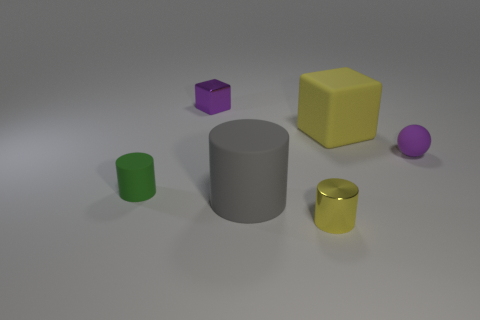There is a large yellow rubber thing; is it the same shape as the metallic thing that is to the left of the gray thing?
Offer a very short reply. Yes. How many small matte things are the same shape as the large gray matte object?
Provide a short and direct response. 1. Is the shape of the large gray object the same as the yellow metal object?
Give a very brief answer. Yes. Is there another small cube of the same color as the small metallic cube?
Your answer should be very brief. No. What number of large things are blue matte blocks or green matte objects?
Your response must be concise. 0. How big is the object that is behind the rubber sphere and in front of the small purple cube?
Your answer should be very brief. Large. There is a small purple shiny block; what number of blocks are in front of it?
Ensure brevity in your answer.  1. There is a rubber object that is in front of the yellow matte object and right of the small yellow thing; what is its shape?
Give a very brief answer. Sphere. There is a small thing that is the same color as the big block; what material is it?
Ensure brevity in your answer.  Metal. What number of cubes are either tiny purple objects or small green rubber things?
Provide a succinct answer. 1. 